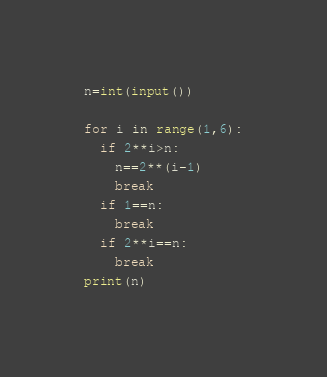<code> <loc_0><loc_0><loc_500><loc_500><_Python_>n=int(input())

for i in range(1,6):
  if 2**i>n:
    n==2**(i-1)
    break
  if 1==n:
    break
  if 2**i==n:
    break
print(n)</code> 